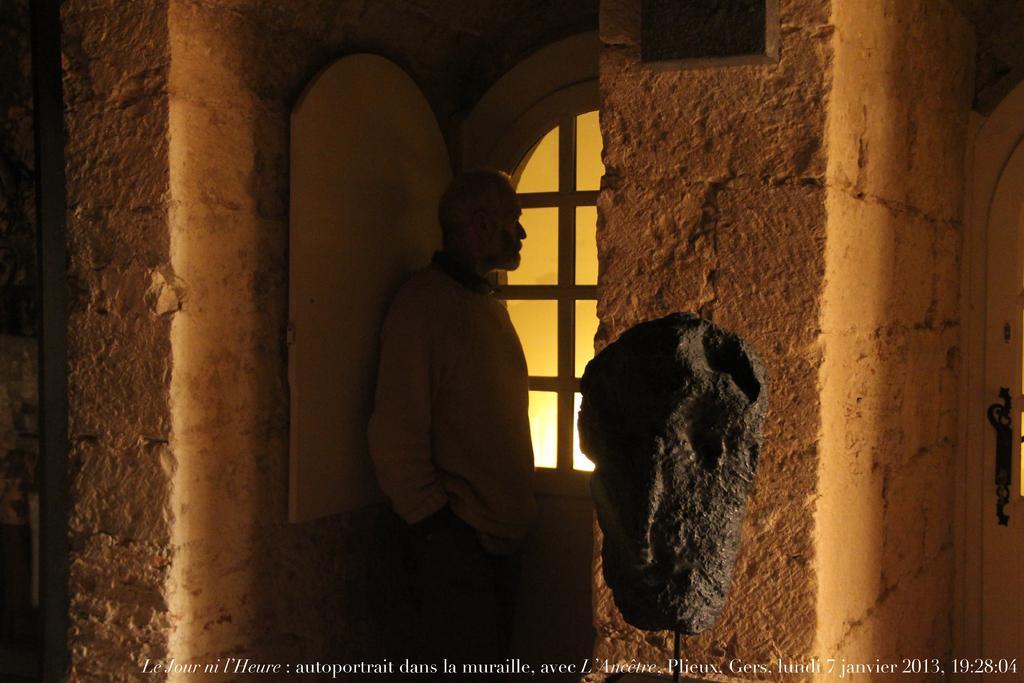How would you summarize this image in a sentence or two? In this image I can see a person standing, the window, the door, the walls which are brown in color and a black colored object. To the right side of the image I can see a door. 